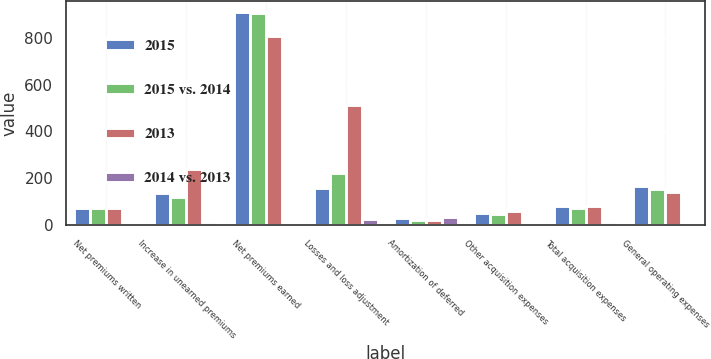Convert chart. <chart><loc_0><loc_0><loc_500><loc_500><stacked_bar_chart><ecel><fcel>Net premiums written<fcel>Increase in unearned premiums<fcel>Net premiums earned<fcel>Losses and loss adjustment<fcel>Amortization of deferred<fcel>Other acquisition expenses<fcel>Total acquisition expenses<fcel>General operating expenses<nl><fcel>2015<fcel>71<fcel>138<fcel>912<fcel>160<fcel>30<fcel>51<fcel>81<fcel>166<nl><fcel>2015 vs. 2014<fcel>71<fcel>120<fcel>904<fcel>223<fcel>22<fcel>49<fcel>71<fcel>156<nl><fcel>2013<fcel>71<fcel>239<fcel>809<fcel>514<fcel>20<fcel>60<fcel>80<fcel>142<nl><fcel>2014 vs. 2013<fcel>3<fcel>15<fcel>1<fcel>28<fcel>36<fcel>4<fcel>14<fcel>6<nl></chart> 